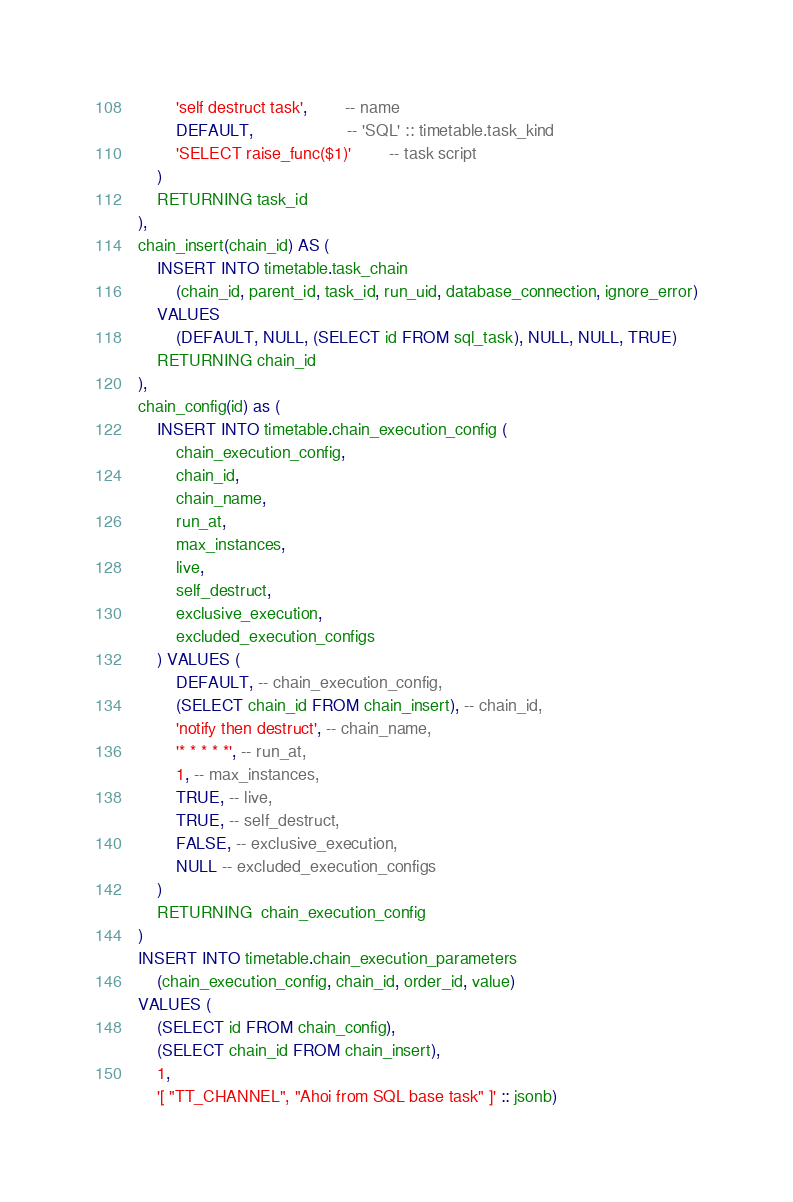Convert code to text. <code><loc_0><loc_0><loc_500><loc_500><_SQL_>		'self destruct task',	    -- name
		DEFAULT, 					-- 'SQL' :: timetable.task_kind
		'SELECT raise_func($1)'		-- task script
	)
	RETURNING task_id
),
chain_insert(chain_id) AS (
    INSERT INTO timetable.task_chain 
        (chain_id, parent_id, task_id, run_uid, database_connection, ignore_error)
    VALUES 
        (DEFAULT, NULL, (SELECT id FROM sql_task), NULL, NULL, TRUE)
    RETURNING chain_id
),
chain_config(id) as (
    INSERT INTO timetable.chain_execution_config (
        chain_execution_config, 
        chain_id, 
        chain_name, 
        run_at, 
        max_instances, 
        live,
        self_destruct, 
        exclusive_execution, 
        excluded_execution_configs
    ) VALUES ( 
        DEFAULT, -- chain_execution_config, 
        (SELECT chain_id FROM chain_insert), -- chain_id, 
        'notify then destruct', -- chain_name, 
        '* * * * *', -- run_at, 
        1, -- max_instances, 
        TRUE, -- live, 
        TRUE, -- self_destruct,
        FALSE, -- exclusive_execution, 
        NULL -- excluded_execution_configs
    )
    RETURNING  chain_execution_config
)
INSERT INTO timetable.chain_execution_parameters 
    (chain_execution_config, chain_id, order_id, value)
VALUES (
    (SELECT id FROM chain_config),
    (SELECT chain_id FROM chain_insert),
    1,
    '[ "TT_CHANNEL", "Ahoi from SQL base task" ]' :: jsonb) </code> 